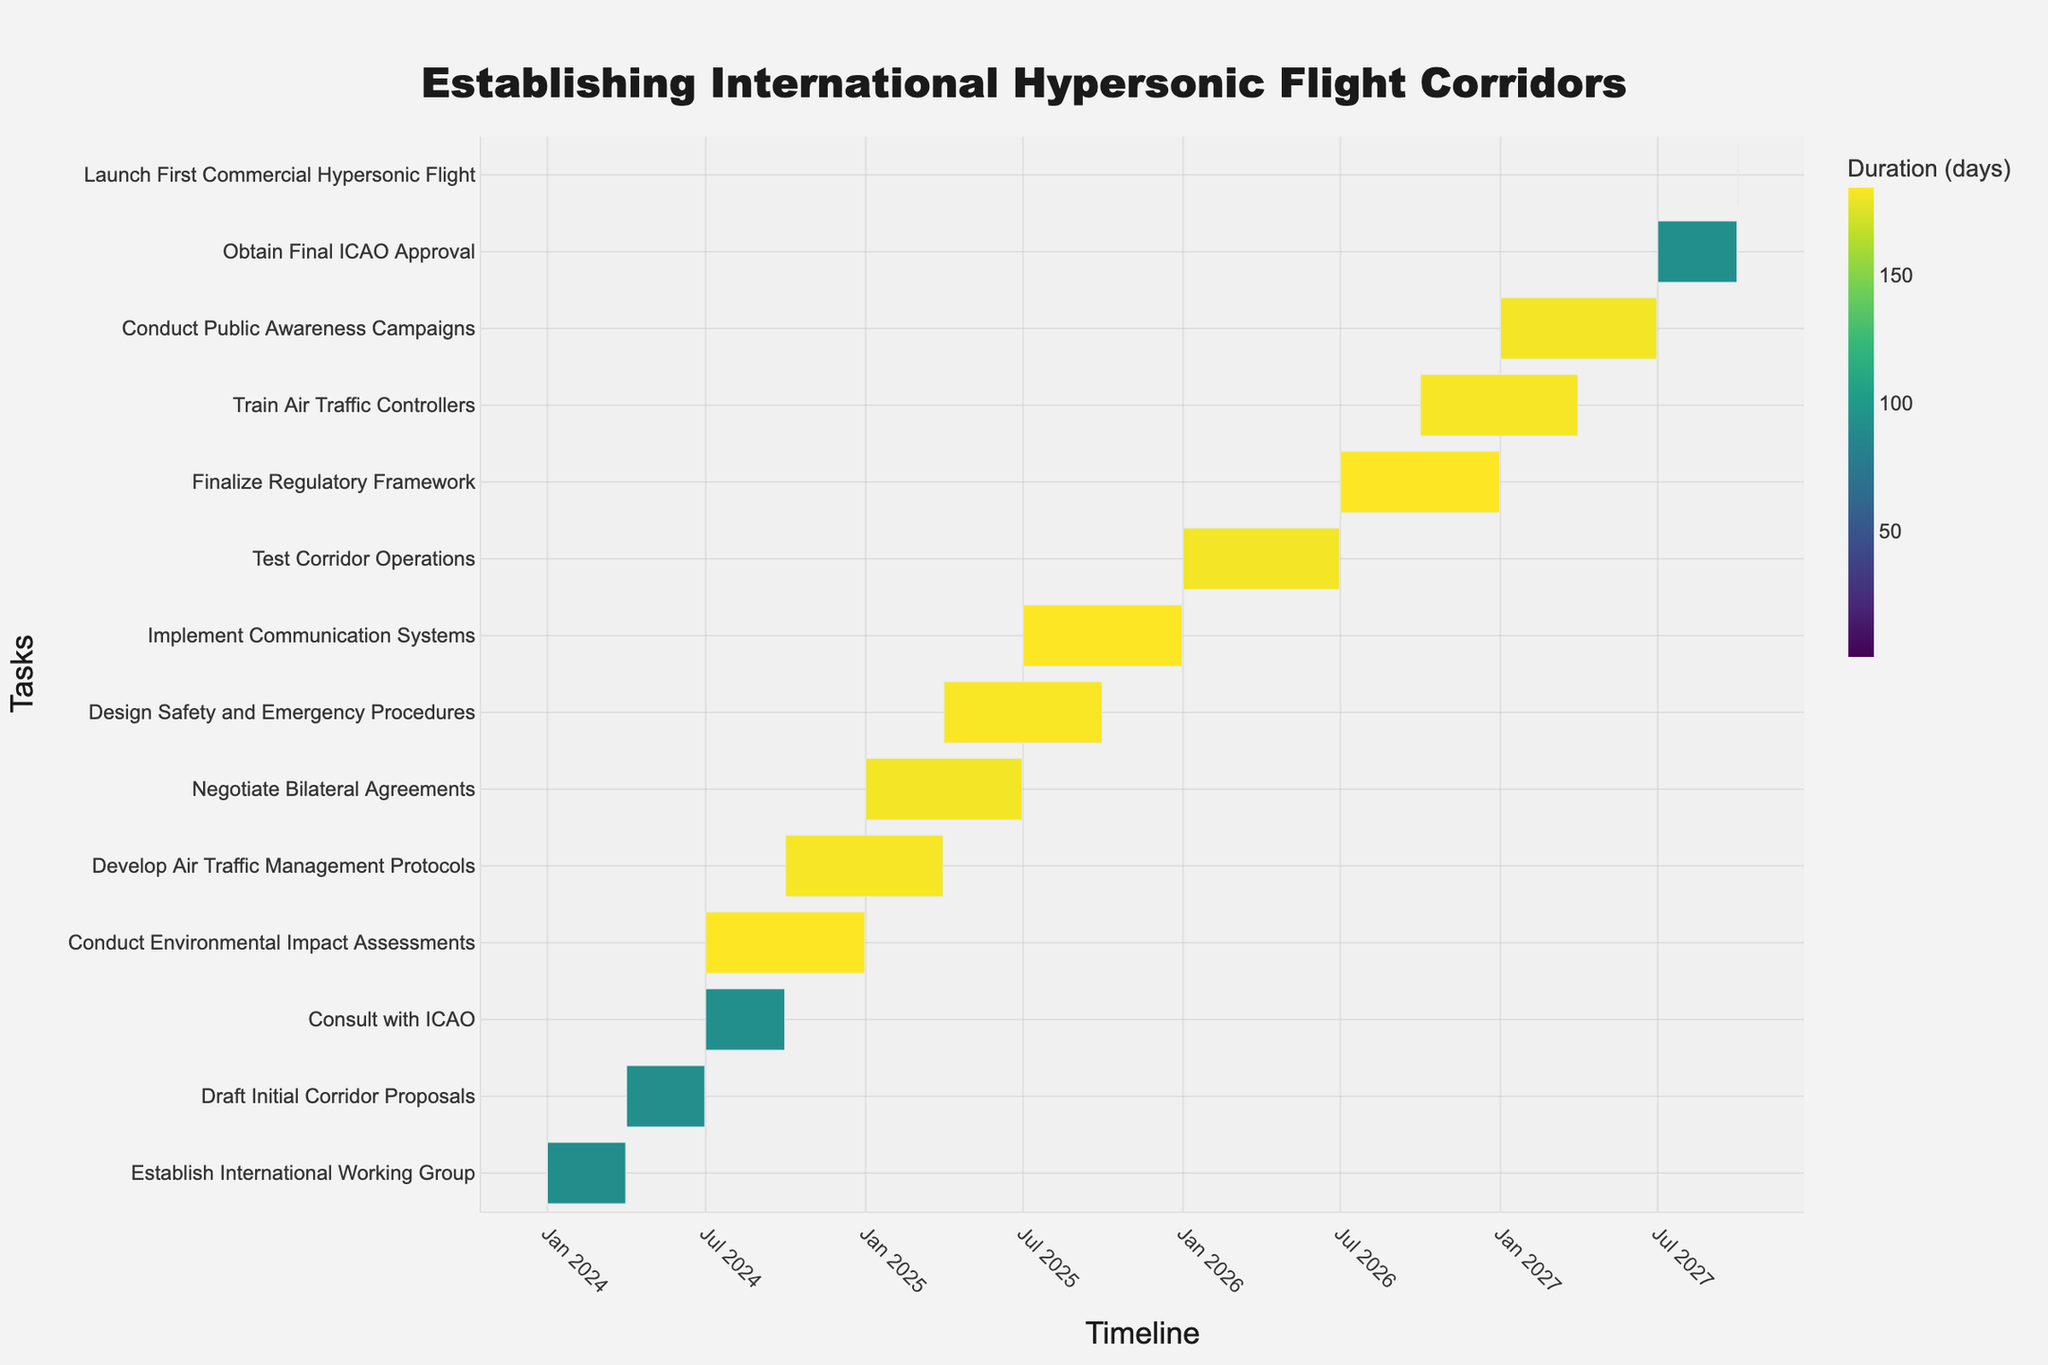When does the task "Establish International Working Group" start and end? The task "Establish International Working Group" starts on January 1, 2024, and ends on March 31, 2024, as indicated by its position on the Gantt chart.
Answer: January 1, 2024 - March 31, 2024 Which task has the longest duration? By looking at the durations of the tasks and matching the longest color gradient bar, "Conduct Environmental Impact Assessments" has the longest duration of 184 days.
Answer: Conduct Environmental Impact Assessments How many tasks are scheduled to start in 2024? To determine how many tasks start in 2024, count the number of tasks with a start date in that year. The tasks are: "Establish International Working Group", "Draft Initial Corridor Proposals", "Consult with ICAO", "Conduct Environmental Impact Assessments", and "Develop Air Traffic Management Protocols". In total, there are 5 tasks.
Answer: 5 What is the total duration for tasks starting in 2025? First, identify the tasks starting in 2025 ("Negotiate Bilateral Agreements", "Design Safety and Emergency Procedures", "Implement Communication Systems") and add their durations: 181 days + 183 days + 184 days = 548 days.
Answer: 548 days Compare the end dates of "Develop Air Traffic Management Protocols" and "Design Safety and Emergency Procedures". Which one finishes first? The task "Develop Air Traffic Management Protocols" ends on March 31, 2025, while "Design Safety and Emergency Procedures" ends on September 30, 2025. Since March 31 is earlier than September 30, "Develop Air Traffic Management Protocols" finishes first.
Answer: Develop Air Traffic Management Protocols How long after the start of "Test Corridor Operations" does "Finalize Regulatory Framework" begin? "Test Corridor Operations" starts on January 1, 2026, and "Finalize Regulatory Framework" starts on July 1, 2026. The time between these dates is 6 months.
Answer: 6 months Which tasks are scheduled to be worked on simultaneously in July 2024? "Consult with ICAO" (July 1, 2024 - September 30, 2024) and "Conduct Environmental Impact Assessments" (July 1, 2024 - December 31, 2024) both start in July 2024, indicating they are worked on simultaneously.
Answer: Consult with ICAO and Conduct Environmental Impact Assessments When is the "Launch First Commercial Hypersonic Flight" scheduled? The "Launch First Commercial Hypersonic Flight" is scheduled on October 1, 2027, as indicated in the Gantt chart.
Answer: October 1, 2027 What is the duration difference between "Train Air Traffic Controllers" and "Conduct Public Awareness Campaigns"? "Train Air Traffic Controllers" has a duration of 182 days, while "Conduct Public Awareness Campaigns" lasts 181 days. The difference is 182 - 181 = 1 day.
Answer: 1 day How does the timeline for "Obtain Final ICAO Approval" overlap with "Conduct Public Awareness Campaigns"? "Conduct Public Awareness Campaigns" runs from January 1, 2027, to June 30, 2027, and "Obtain Final ICAO Approval" runs from July 1, 2027 to September 30, 2027. Therefore, there is no overlap between these timelines.
Answer: No overlap 